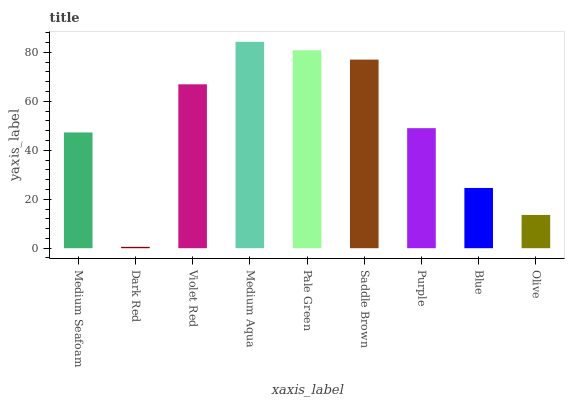Is Dark Red the minimum?
Answer yes or no. Yes. Is Medium Aqua the maximum?
Answer yes or no. Yes. Is Violet Red the minimum?
Answer yes or no. No. Is Violet Red the maximum?
Answer yes or no. No. Is Violet Red greater than Dark Red?
Answer yes or no. Yes. Is Dark Red less than Violet Red?
Answer yes or no. Yes. Is Dark Red greater than Violet Red?
Answer yes or no. No. Is Violet Red less than Dark Red?
Answer yes or no. No. Is Purple the high median?
Answer yes or no. Yes. Is Purple the low median?
Answer yes or no. Yes. Is Olive the high median?
Answer yes or no. No. Is Olive the low median?
Answer yes or no. No. 